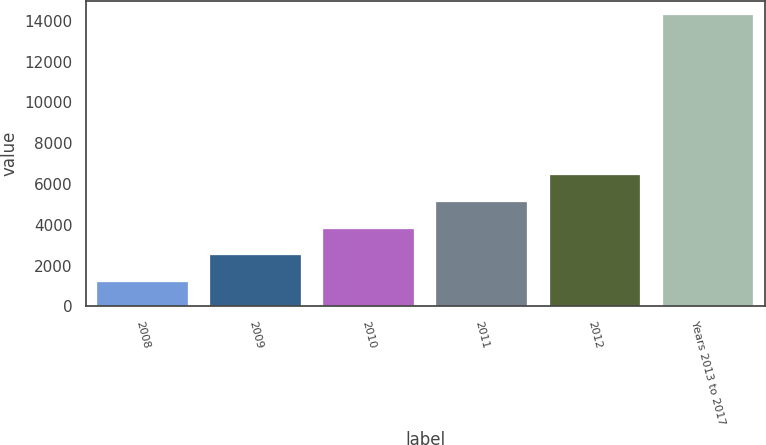Convert chart. <chart><loc_0><loc_0><loc_500><loc_500><bar_chart><fcel>2008<fcel>2009<fcel>2010<fcel>2011<fcel>2012<fcel>Years 2013 to 2017<nl><fcel>1197<fcel>2505.3<fcel>3813.6<fcel>5121.9<fcel>6430.2<fcel>14280<nl></chart> 